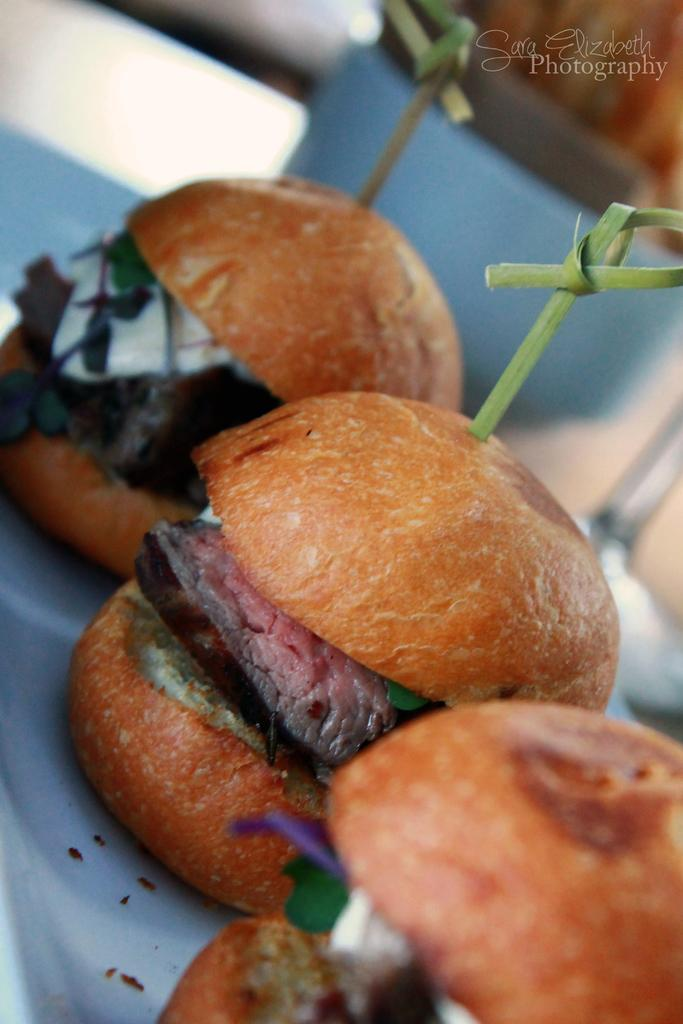What type of food can be seen in the image? There are sandwiches in the image. How are the sandwiches arranged or contained? The sandwiches are in a tray. Is there any additional information or marking in the image? Yes, there is a watermark in the top right corner of the image. What year is depicted in the image? The image does not depict a specific year; it only shows sandwiches in a tray with a watermark in the top right corner. How many crates are visible in the image? There are no crates present in the image; it only shows sandwiches in a tray. 